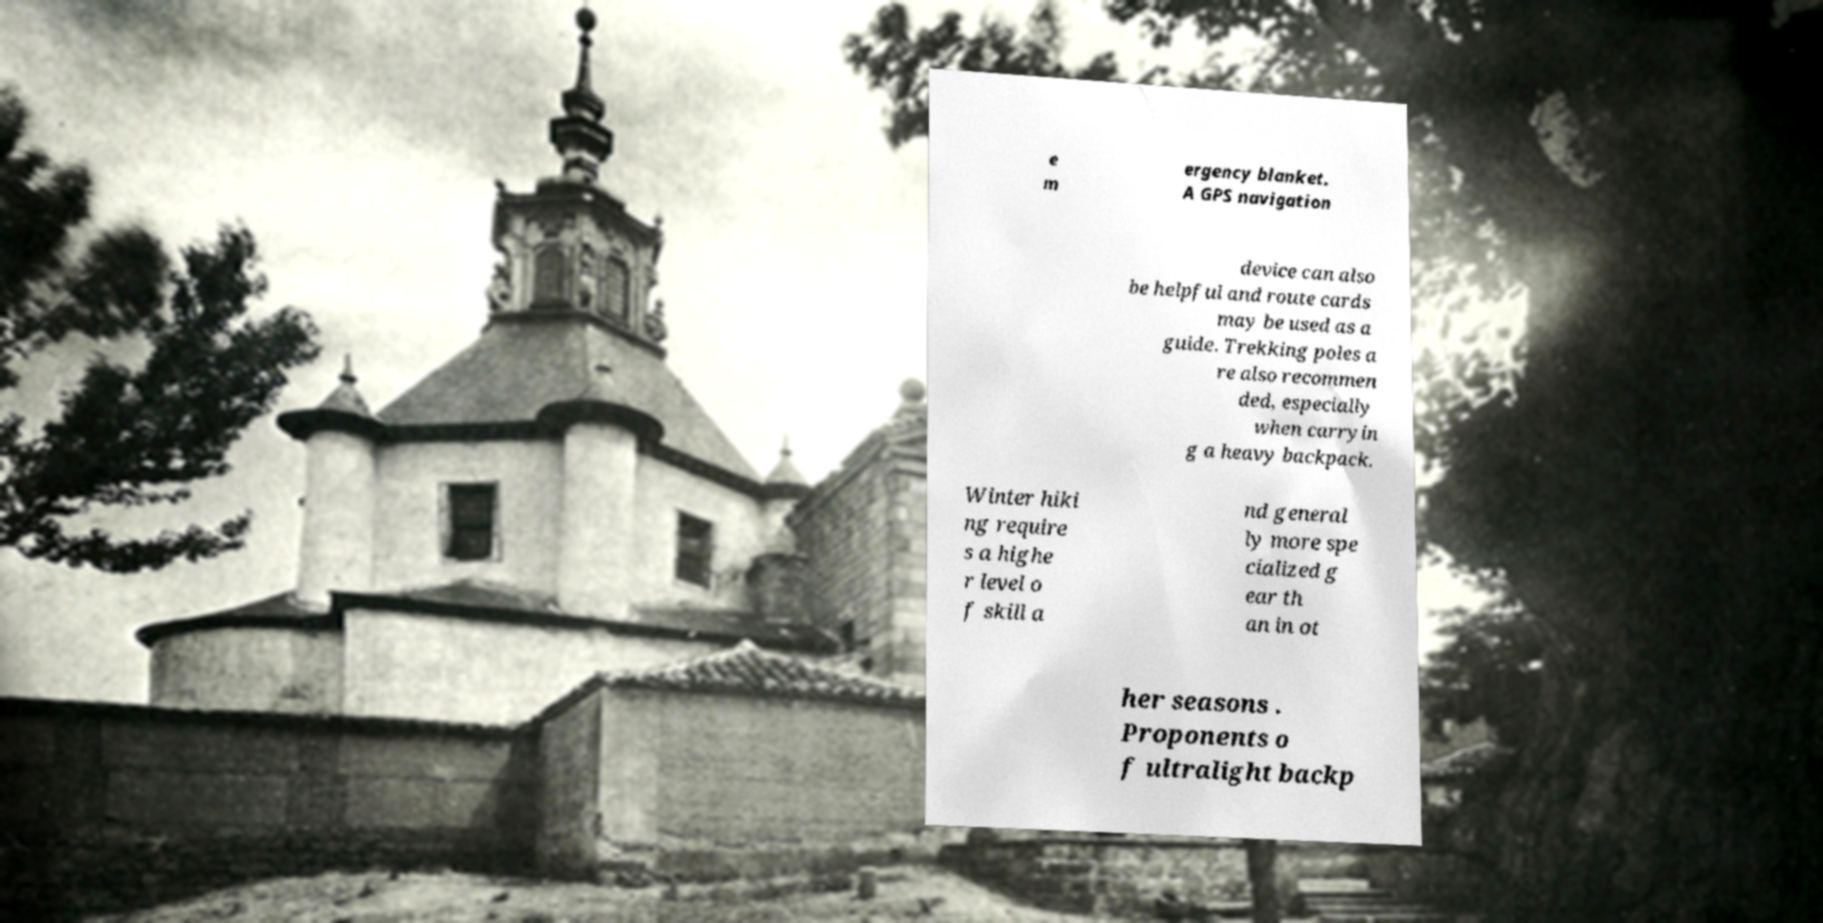Please read and relay the text visible in this image. What does it say? e m ergency blanket. A GPS navigation device can also be helpful and route cards may be used as a guide. Trekking poles a re also recommen ded, especially when carryin g a heavy backpack. Winter hiki ng require s a highe r level o f skill a nd general ly more spe cialized g ear th an in ot her seasons . Proponents o f ultralight backp 